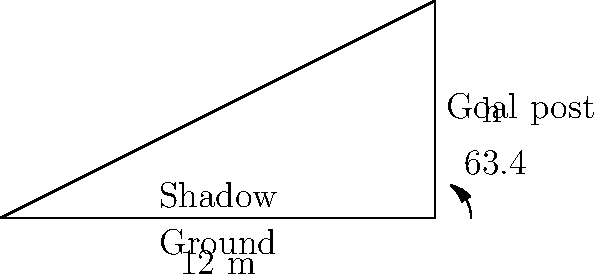During a sunny afternoon at the football stadium, you notice the shadow cast by the goal post. The length of the shadow is 12 meters, and the angle of elevation of the sun is 63.4°. Using trigonometry, can you determine the height of the goal post? Let's approach this step-by-step:

1) First, we need to identify the trigonometric relationship in this scenario. We have:
   - The adjacent side (shadow length) = 12 meters
   - The angle of elevation = 63.4°
   - We need to find the opposite side (height of the goal post)

2) This forms a right-angled triangle where we know the adjacent side and the angle. The trigonometric ratio that relates the opposite side to the adjacent side is the tangent.

3) The tangent of an angle is defined as:
   $\tan \theta = \frac{\text{opposite}}{\text{adjacent}}$

4) In our case:
   $\tan 63.4° = \frac{\text{height}}{\text{shadow length}}$

5) Let's call the height $h$. We can write:
   $\tan 63.4° = \frac{h}{12}$

6) To solve for $h$, we multiply both sides by 12:
   $12 \tan 63.4° = h$

7) Now we just need to calculate this:
   $h = 12 \times \tan 63.4°$
   $h = 12 \times 1.9891$
   $h = 23.8692$ meters

8) Rounding to one decimal place:
   $h \approx 23.9$ meters
Answer: 23.9 meters 